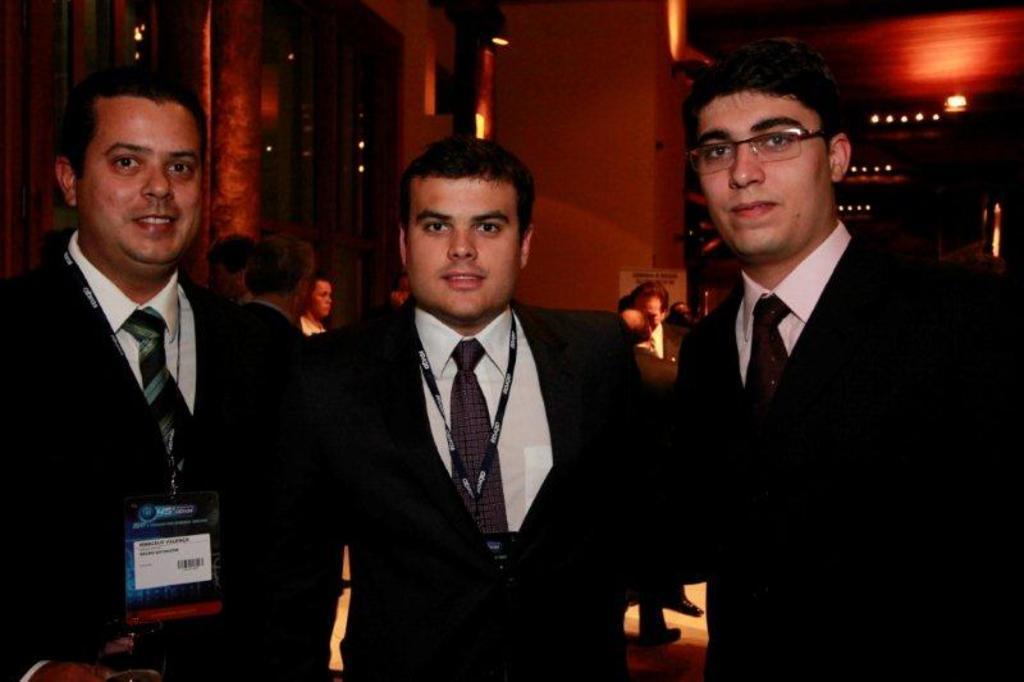Please provide a concise description of this image. Front these three people are standing and wore black suits. Background there are people and lights. 